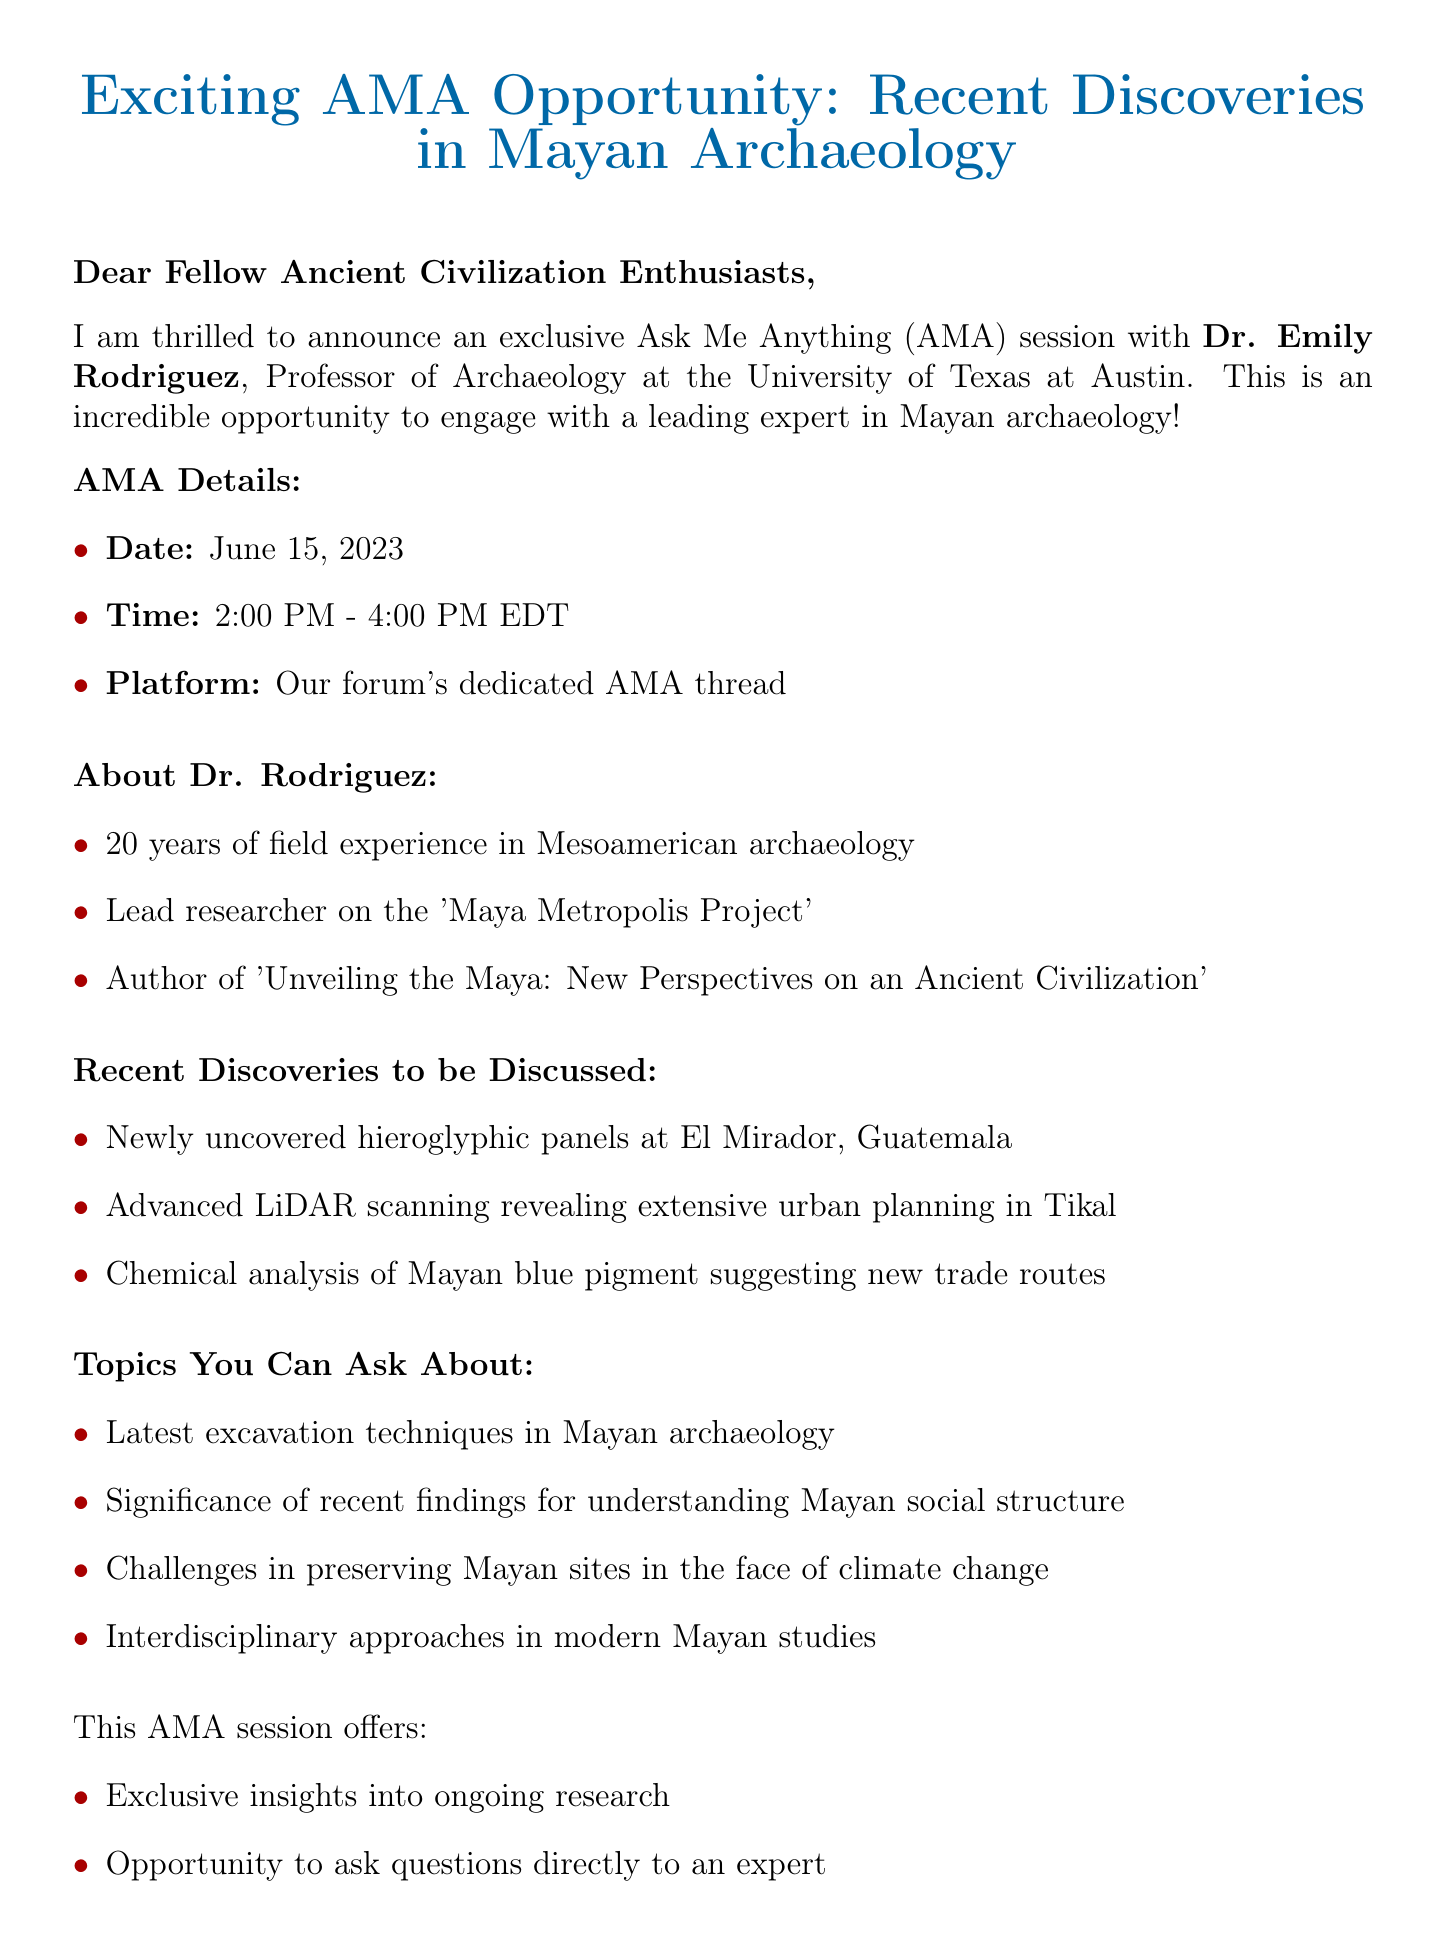What is the name of the professor hosting the AMA? The document states that the professor hosting the AMA is Dr. Emily Rodriguez.
Answer: Dr. Emily Rodriguez What is the date of the AMA session? According to the document, the AMA session will take place on June 15, 2023.
Answer: June 15, 2023 What time does the AMA session start? The document mentions that the AMA session starts at 2:00 PM EDT.
Answer: 2:00 PM What university is Dr. Rodriguez affiliated with? The document indicates that Dr. Rodriguez is affiliated with the University of Texas at Austin.
Answer: University of Texas at Austin What is one recent discovery mentioned in the document? The document lists several discoveries, one of which is newly uncovered hieroglyphic panels at El Mirador, Guatemala.
Answer: Newly uncovered hieroglyphic panels at El Mirador, Guatemala How many years of field experience does Dr. Rodriguez have? The document states that Dr. Rodriguez has 20 years of field experience in Mesoamerican archaeology.
Answer: 20 years What is one of the topics forum members can ask about? The document includes the significance of recent findings for understanding Mayan social structure as a topic.
Answer: Significance of recent findings for understanding Mayan social structure What opportunity does the AMA provide directly to forum members? The document specifies that the AMA offers an opportunity for forum members to ask questions directly to an expert.
Answer: Ask questions directly to an expert What is Dr. Rodriguez's office phone number? The document provides Dr. Rodriguez's office phone number as +1 (512) 471-5000.
Answer: +1 (512) 471-5000 